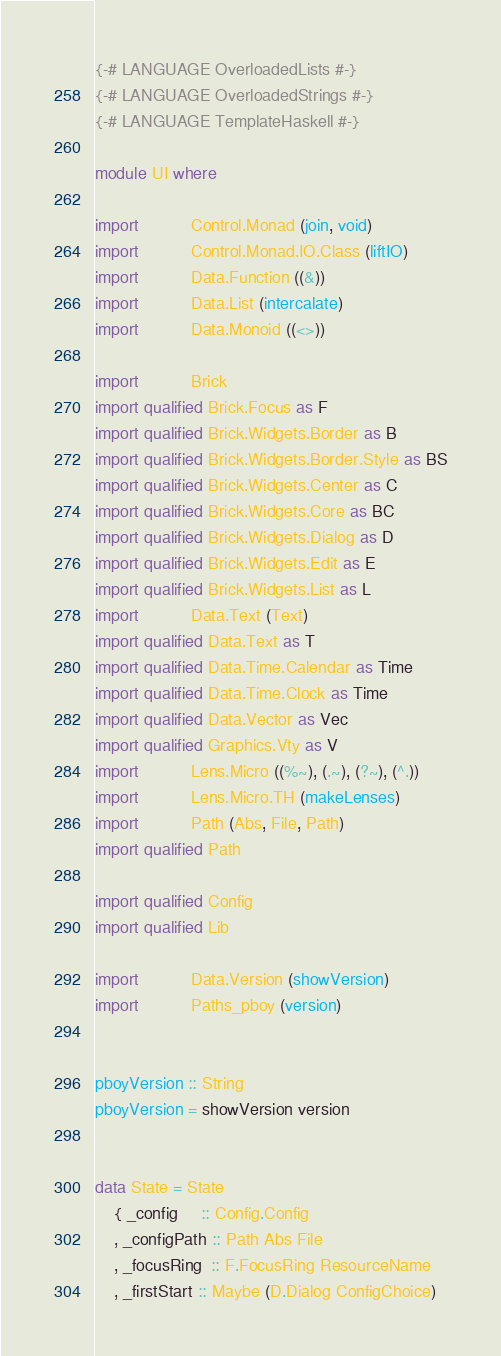<code> <loc_0><loc_0><loc_500><loc_500><_Haskell_>{-# LANGUAGE OverloadedLists #-}
{-# LANGUAGE OverloadedStrings #-}
{-# LANGUAGE TemplateHaskell #-}

module UI where

import           Control.Monad (join, void)
import           Control.Monad.IO.Class (liftIO)
import           Data.Function ((&))
import           Data.List (intercalate)
import           Data.Monoid ((<>))

import           Brick
import qualified Brick.Focus as F
import qualified Brick.Widgets.Border as B
import qualified Brick.Widgets.Border.Style as BS
import qualified Brick.Widgets.Center as C
import qualified Brick.Widgets.Core as BC
import qualified Brick.Widgets.Dialog as D
import qualified Brick.Widgets.Edit as E
import qualified Brick.Widgets.List as L
import           Data.Text (Text)
import qualified Data.Text as T
import qualified Data.Time.Calendar as Time
import qualified Data.Time.Clock as Time
import qualified Data.Vector as Vec
import qualified Graphics.Vty as V
import           Lens.Micro ((%~), (.~), (?~), (^.))
import           Lens.Micro.TH (makeLenses)
import           Path (Abs, File, Path)
import qualified Path

import qualified Config
import qualified Lib

import           Data.Version (showVersion)
import           Paths_pboy (version)


pboyVersion :: String
pboyVersion = showVersion version


data State = State
    { _config     :: Config.Config
    , _configPath :: Path Abs File
    , _focusRing  :: F.FocusRing ResourceName
    , _firstStart :: Maybe (D.Dialog ConfigChoice)</code> 